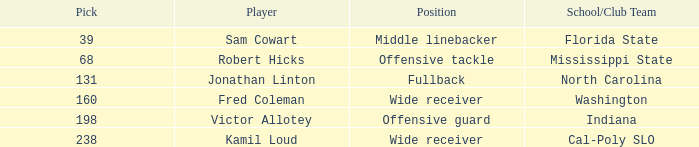Which Player has a Round smaller than 5, and a School/Club Team of florida state? Sam Cowart. 